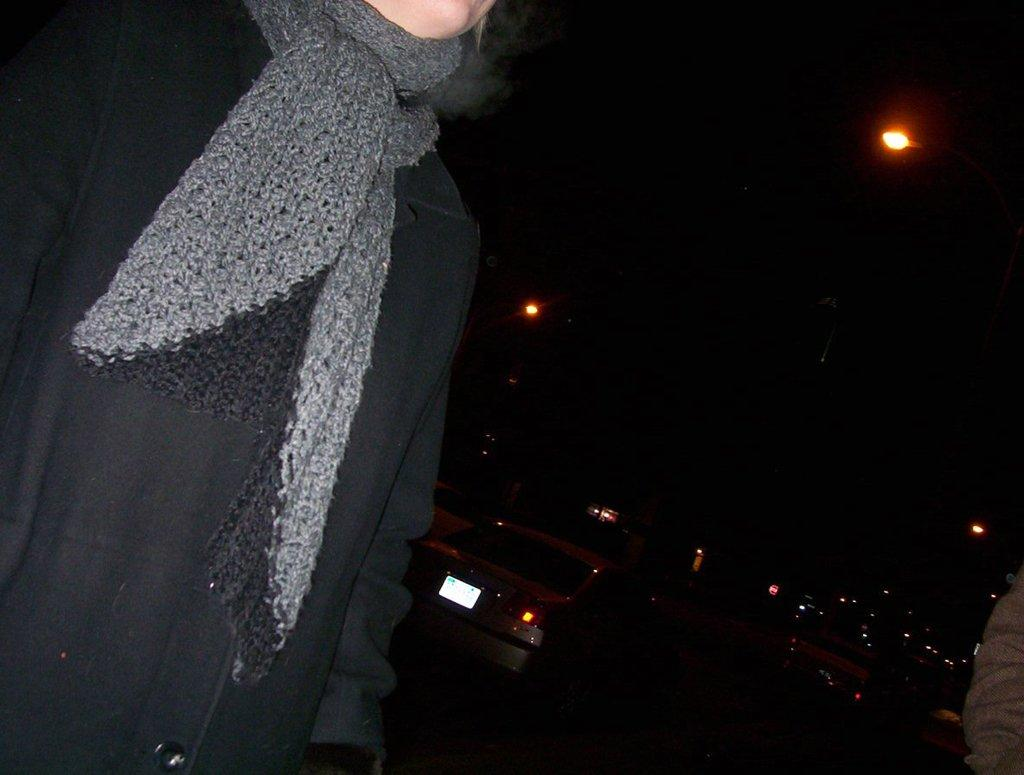What is located on the left side of the image? There is a person on the left side of the image. What can be seen in the background of the image? There are vehicles on the road and street lights in the background of the image. Can you describe the hand visible in the bottom right corner of the image? There is a person's hand visible in the bottom right corner of the image. What invention is being demonstrated by the person in the image? There is no invention being demonstrated in the image; it simply shows a person on the left side and vehicles and street lights in the background. 